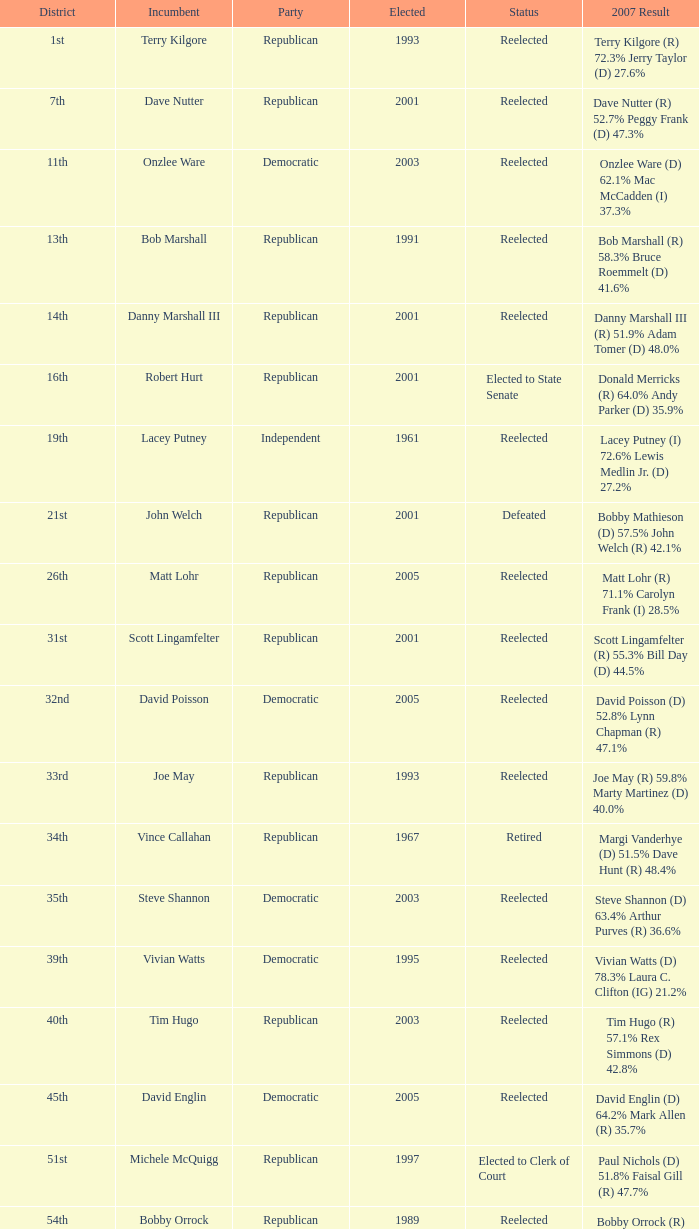Can you parse all the data within this table? {'header': ['District', 'Incumbent', 'Party', 'Elected', 'Status', '2007 Result'], 'rows': [['1st', 'Terry Kilgore', 'Republican', '1993', 'Reelected', 'Terry Kilgore (R) 72.3% Jerry Taylor (D) 27.6%'], ['7th', 'Dave Nutter', 'Republican', '2001', 'Reelected', 'Dave Nutter (R) 52.7% Peggy Frank (D) 47.3%'], ['11th', 'Onzlee Ware', 'Democratic', '2003', 'Reelected', 'Onzlee Ware (D) 62.1% Mac McCadden (I) 37.3%'], ['13th', 'Bob Marshall', 'Republican', '1991', 'Reelected', 'Bob Marshall (R) 58.3% Bruce Roemmelt (D) 41.6%'], ['14th', 'Danny Marshall III', 'Republican', '2001', 'Reelected', 'Danny Marshall III (R) 51.9% Adam Tomer (D) 48.0%'], ['16th', 'Robert Hurt', 'Republican', '2001', 'Elected to State Senate', 'Donald Merricks (R) 64.0% Andy Parker (D) 35.9%'], ['19th', 'Lacey Putney', 'Independent', '1961', 'Reelected', 'Lacey Putney (I) 72.6% Lewis Medlin Jr. (D) 27.2%'], ['21st', 'John Welch', 'Republican', '2001', 'Defeated', 'Bobby Mathieson (D) 57.5% John Welch (R) 42.1%'], ['26th', 'Matt Lohr', 'Republican', '2005', 'Reelected', 'Matt Lohr (R) 71.1% Carolyn Frank (I) 28.5%'], ['31st', 'Scott Lingamfelter', 'Republican', '2001', 'Reelected', 'Scott Lingamfelter (R) 55.3% Bill Day (D) 44.5%'], ['32nd', 'David Poisson', 'Democratic', '2005', 'Reelected', 'David Poisson (D) 52.8% Lynn Chapman (R) 47.1%'], ['33rd', 'Joe May', 'Republican', '1993', 'Reelected', 'Joe May (R) 59.8% Marty Martinez (D) 40.0%'], ['34th', 'Vince Callahan', 'Republican', '1967', 'Retired', 'Margi Vanderhye (D) 51.5% Dave Hunt (R) 48.4%'], ['35th', 'Steve Shannon', 'Democratic', '2003', 'Reelected', 'Steve Shannon (D) 63.4% Arthur Purves (R) 36.6%'], ['39th', 'Vivian Watts', 'Democratic', '1995', 'Reelected', 'Vivian Watts (D) 78.3% Laura C. Clifton (IG) 21.2%'], ['40th', 'Tim Hugo', 'Republican', '2003', 'Reelected', 'Tim Hugo (R) 57.1% Rex Simmons (D) 42.8%'], ['45th', 'David Englin', 'Democratic', '2005', 'Reelected', 'David Englin (D) 64.2% Mark Allen (R) 35.7%'], ['51st', 'Michele McQuigg', 'Republican', '1997', 'Elected to Clerk of Court', 'Paul Nichols (D) 51.8% Faisal Gill (R) 47.7%'], ['54th', 'Bobby Orrock', 'Republican', '1989', 'Reelected', 'Bobby Orrock (R) 73.7% Kimbra Kincheloe (I) 26.2%'], ['56th', 'Bill Janis', 'Republican', '2001', 'Reelected', 'Bill Janis (R) 65.9% Will Shaw (D) 34.0%'], ['59th', 'Watkins Abbitt', 'Independent', '1985', 'Reelected', 'Watkins Abbitt (I) 60.2% Connie Brennan (D) 39.7%'], ['67th', 'Chuck Caputo', 'Democratic', '2005', 'Reelected', 'Chuck Caputo (D) 52.7% Marc Cadin (R) 47.3%'], ['69th', 'Frank Hall', 'Democratic', '1975', 'Reelected', 'Frank Hall (D) 82.8% Ray Gargiulo (R) 17.0%'], ['72nd', 'Jack Reid', 'Republican', '1989', 'Retired', 'Jimmie Massie (R) 67.2% Tom Herbert (D) 32.7%'], ['78th', 'John Cosgrove', 'Republican', '2001', 'Reelected', 'John Cosgrove (R) 61.7% Mick Meyer (D) 38.2%'], ['82nd', 'Bob Purkey', 'Republican', '1985', 'Reelected', 'Bob Purkey (R) 60.6% Bob MacIver (D) 39.2%'], ['83rd', 'Leo Wardrup', 'Republican', '1991', 'Retired', 'Joe Bouchard (D) 50.6% Chris Stolle (R) 49.2%'], ['86th', 'Tom Rust', 'Republican', '2001', 'Reelected', 'Tom Rust (R) 52.8% Jay Donahue (D) 47.1%'], ['87th', 'Paula Miller', 'Democratic', '2005', 'Reelected', 'Paula Miller (D) 54.0% Hank Giffin (R) 45.8%'], ['88th', 'Mark Cole', 'Republican', '2001', 'Reelected', 'Mark Cole (R) 62.2% Carlos Del Toro (D) 37.6%']]} What district is incument terry kilgore from? 1st. 